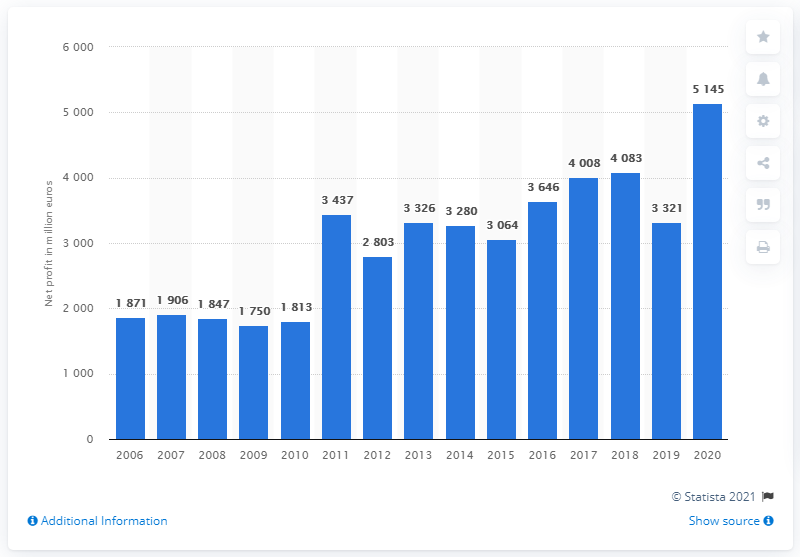Draw attention to some important aspects in this diagram. In 2020, the profit attributable to SAP was 5,145. 